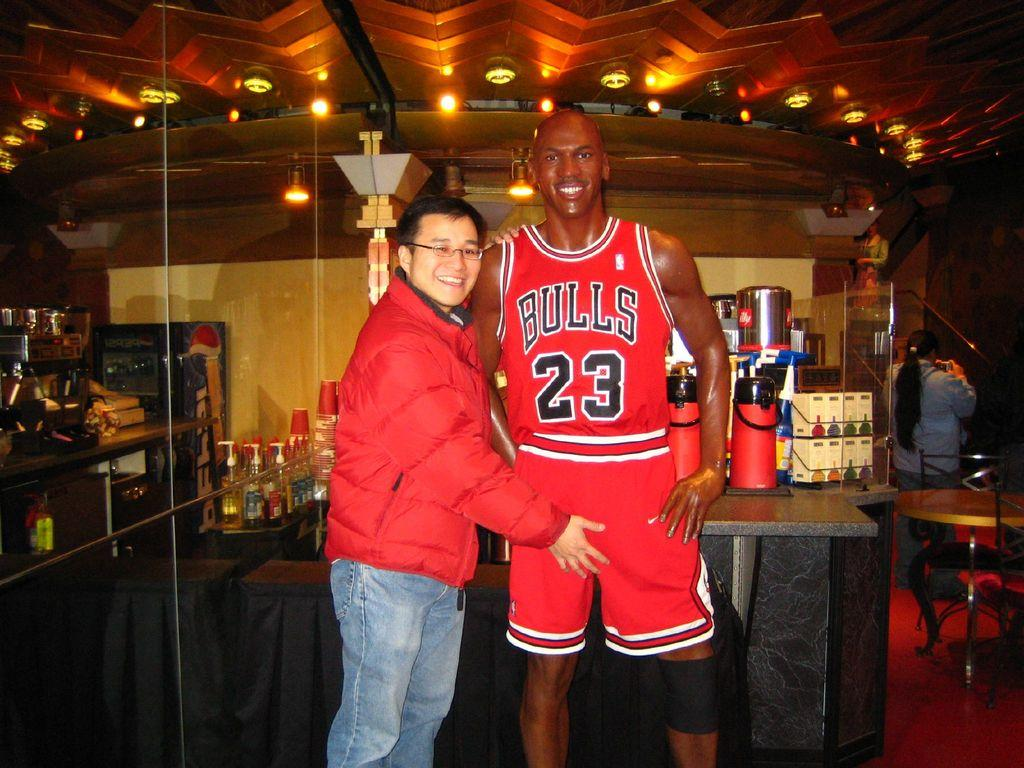<image>
Share a concise interpretation of the image provided. A man standing next to a Bulls player wearing number 23. 